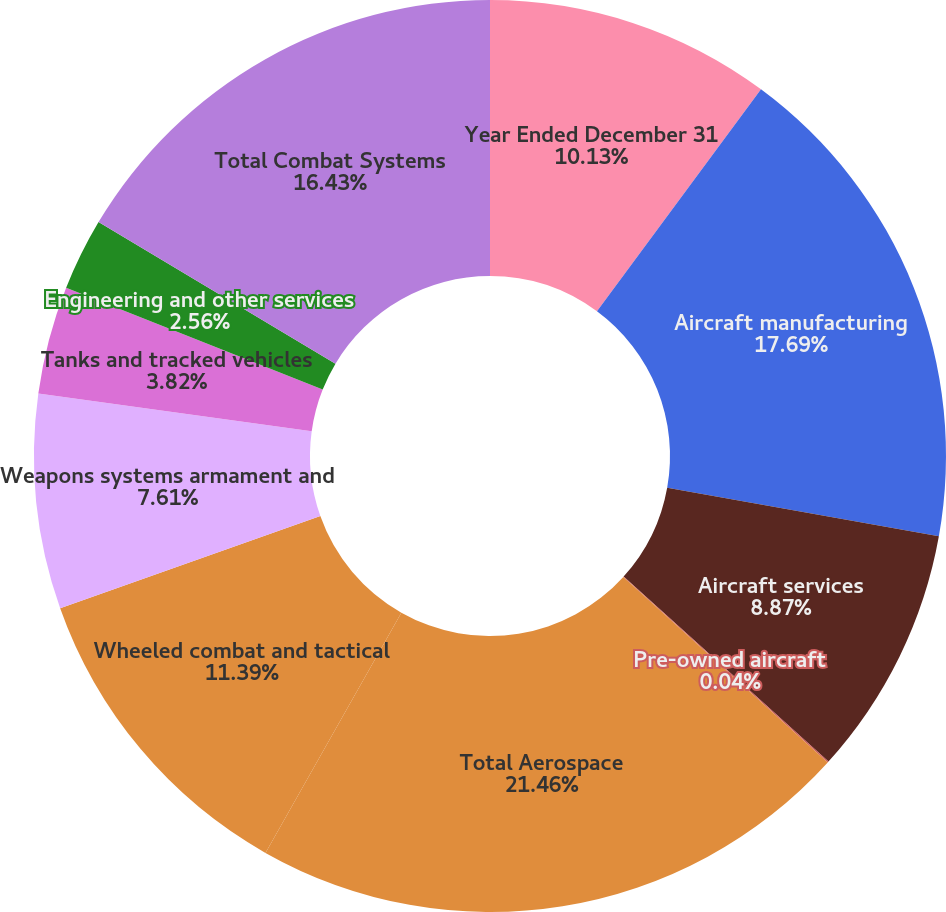<chart> <loc_0><loc_0><loc_500><loc_500><pie_chart><fcel>Year Ended December 31<fcel>Aircraft manufacturing<fcel>Aircraft services<fcel>Pre-owned aircraft<fcel>Total Aerospace<fcel>Wheeled combat and tactical<fcel>Weapons systems armament and<fcel>Tanks and tracked vehicles<fcel>Engineering and other services<fcel>Total Combat Systems<nl><fcel>10.13%<fcel>17.69%<fcel>8.87%<fcel>0.04%<fcel>21.47%<fcel>11.39%<fcel>7.61%<fcel>3.82%<fcel>2.56%<fcel>16.43%<nl></chart> 